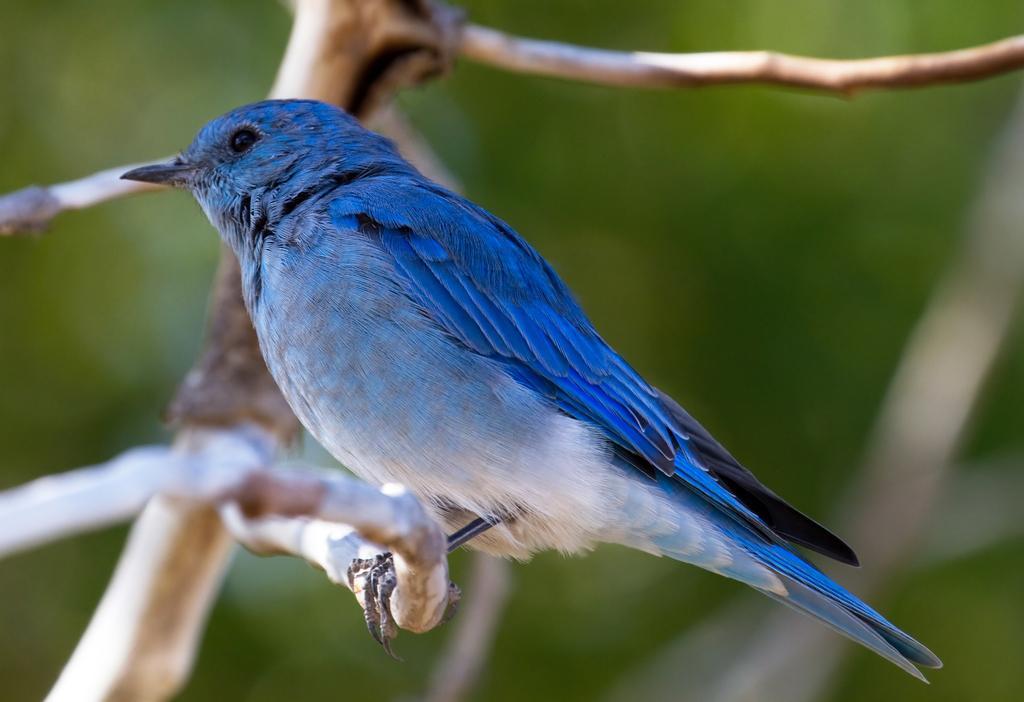In one or two sentences, can you explain what this image depicts? In this picture there is a beautiful blue color bird sitting on the tree branch. Behind there is a green color blur background. 